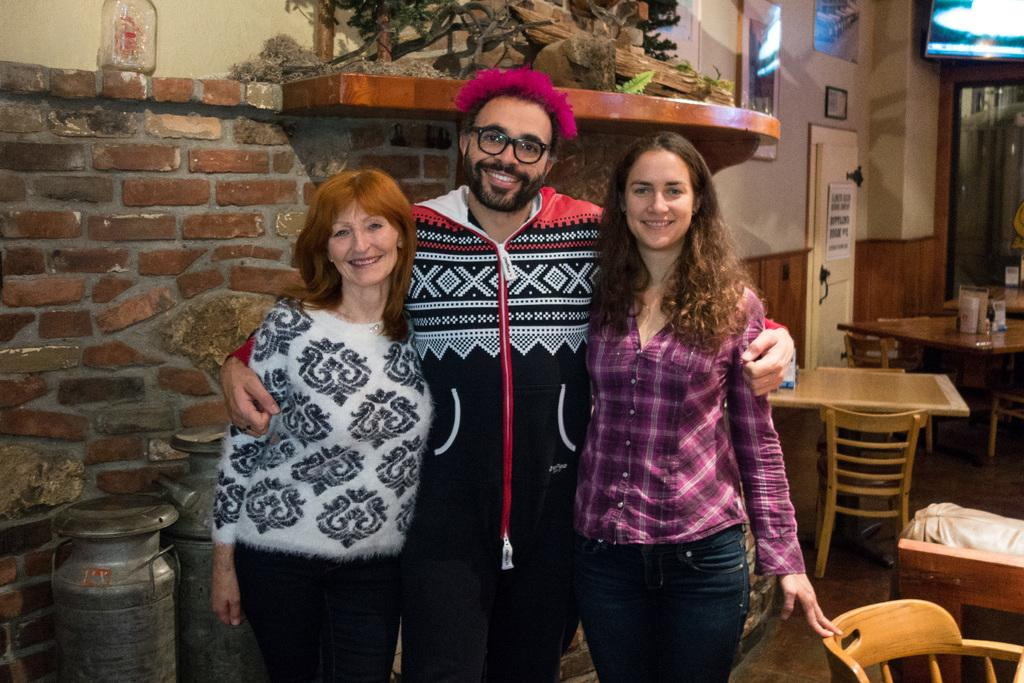How many men are present in the image? There are two men in the image. Can you describe the facial expression of one of the men? There is a man standing with a smile on his face. What type of furniture is visible in the image? There are view tables and chairs in the image. What color is the pin that the man's brother is wearing in the image? There is no mention of a pin or a brother in the image, so we cannot answer this question. 